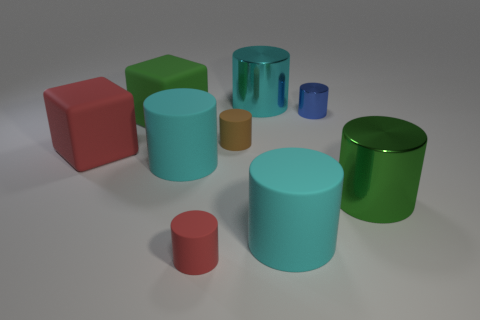What is the shape of the tiny shiny object?
Make the answer very short. Cylinder. There is a red object in front of the red block that is in front of the small brown cylinder; how many green metal cylinders are in front of it?
Your answer should be very brief. 0. How many other things are there of the same material as the big red block?
Your response must be concise. 5. There is a red cube that is the same size as the cyan metallic thing; what is it made of?
Give a very brief answer. Rubber. Does the tiny cylinder that is in front of the red matte block have the same color as the large metal object that is behind the tiny metal cylinder?
Provide a short and direct response. No. Are there any big metallic things that have the same shape as the tiny blue object?
Offer a very short reply. Yes. There is a green thing that is the same size as the green metallic cylinder; what shape is it?
Offer a terse response. Cube. How big is the object that is to the right of the small blue object?
Your response must be concise. Large. What number of cylinders are the same size as the red rubber cube?
Offer a terse response. 4. What color is the tiny cylinder that is the same material as the brown object?
Keep it short and to the point. Red. 